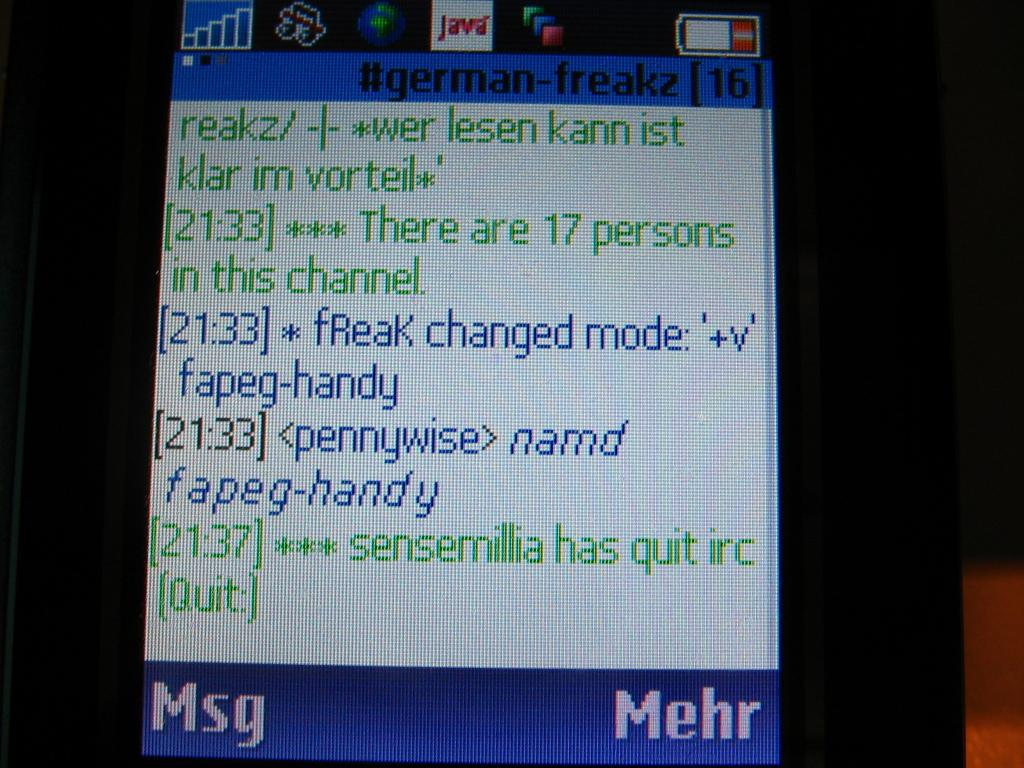Provide a one-sentence caption for the provided image. Screen in blue and white showing that 17 people have joined the channel. 